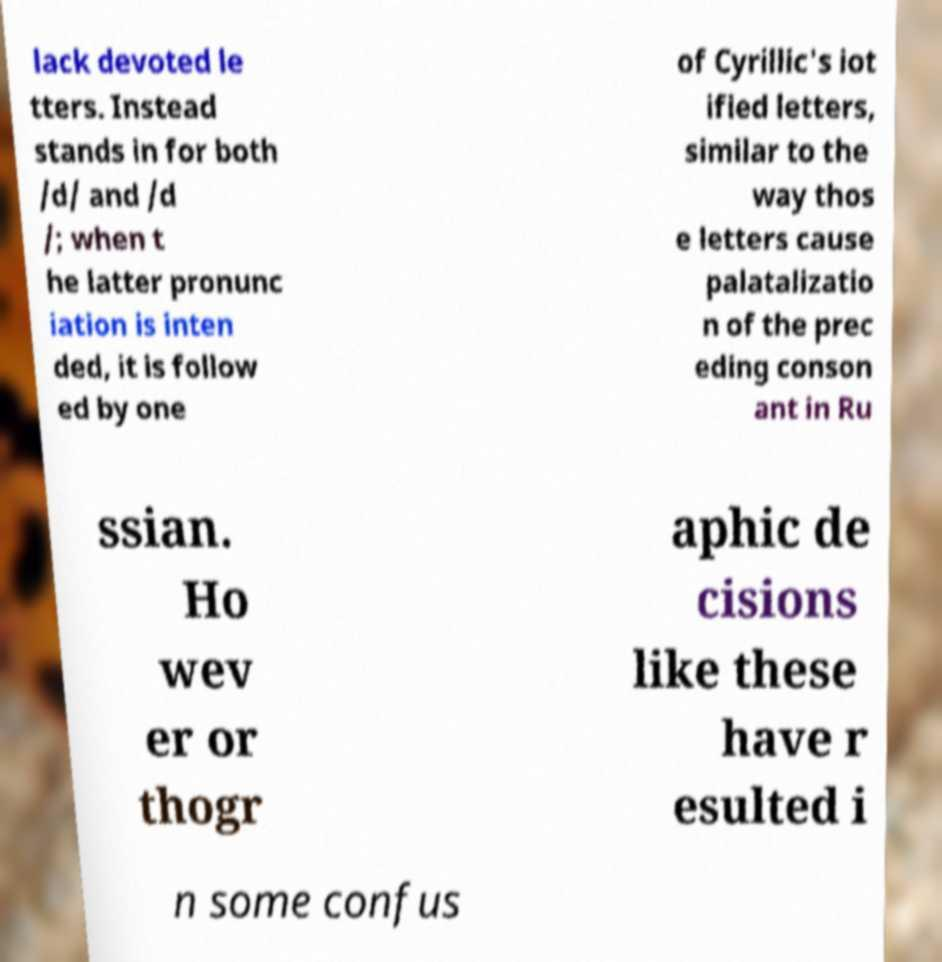Could you extract and type out the text from this image? lack devoted le tters. Instead stands in for both /d/ and /d /; when t he latter pronunc iation is inten ded, it is follow ed by one of Cyrillic's iot ified letters, similar to the way thos e letters cause palatalizatio n of the prec eding conson ant in Ru ssian. Ho wev er or thogr aphic de cisions like these have r esulted i n some confus 